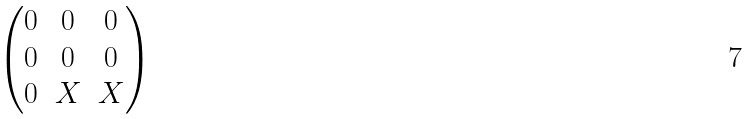<formula> <loc_0><loc_0><loc_500><loc_500>\begin{pmatrix} 0 & 0 & 0 \\ 0 & 0 & 0 \\ 0 & X & X \\ \end{pmatrix}</formula> 